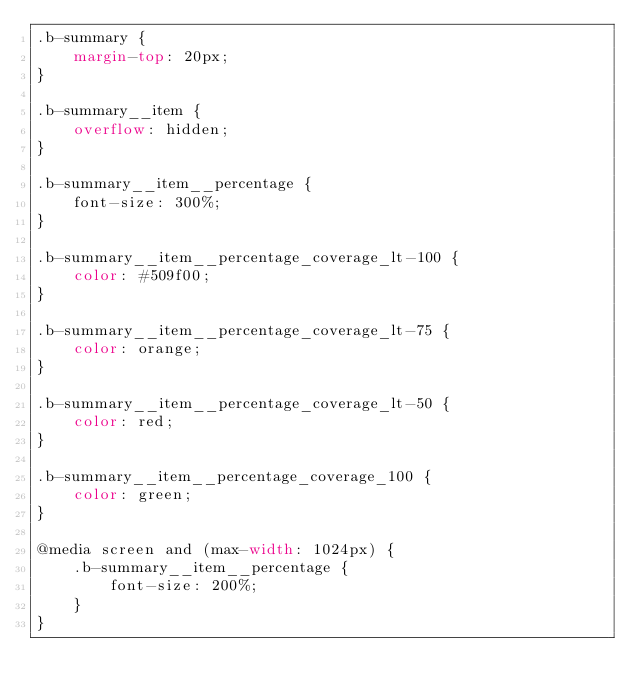<code> <loc_0><loc_0><loc_500><loc_500><_CSS_>.b-summary {
    margin-top: 20px;
}

.b-summary__item {
    overflow: hidden;
}

.b-summary__item__percentage {
    font-size: 300%;
}

.b-summary__item__percentage_coverage_lt-100 {
    color: #509f00;
}

.b-summary__item__percentage_coverage_lt-75 {
    color: orange;
}

.b-summary__item__percentage_coverage_lt-50 {
    color: red;
}

.b-summary__item__percentage_coverage_100 {
    color: green;
}

@media screen and (max-width: 1024px) {
    .b-summary__item__percentage {
        font-size: 200%;
    }
}</code> 